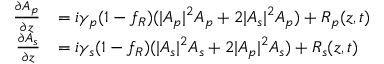<formula> <loc_0><loc_0><loc_500><loc_500>\begin{array} { r l } { \frac { \partial A _ { p } } { \partial z } } & { = i \gamma _ { p } ( 1 - f _ { R } ) ( | A _ { p } | ^ { 2 } A _ { p } + 2 | A _ { s } | ^ { 2 } A _ { p } ) + R _ { p } ( z , t ) } \\ { \frac { \partial A _ { s } } { \partial z } } & { = i \gamma _ { s } ( 1 - f _ { R } ) ( | A _ { s } | ^ { 2 } A _ { s } + 2 | A _ { p } | ^ { 2 } A _ { s } ) + R _ { s } ( z , t ) } \end{array}</formula> 